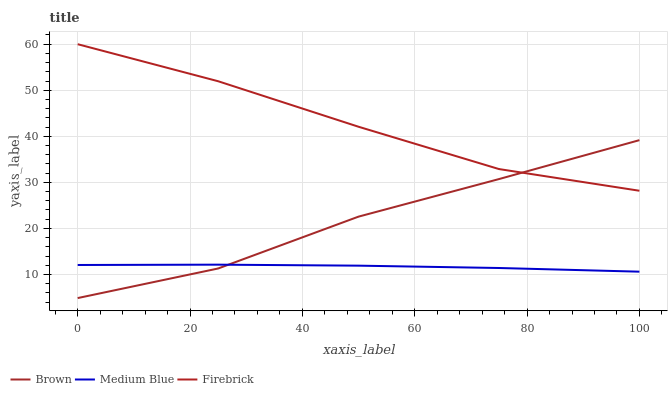Does Medium Blue have the minimum area under the curve?
Answer yes or no. Yes. Does Firebrick have the maximum area under the curve?
Answer yes or no. Yes. Does Firebrick have the minimum area under the curve?
Answer yes or no. No. Does Medium Blue have the maximum area under the curve?
Answer yes or no. No. Is Medium Blue the smoothest?
Answer yes or no. Yes. Is Brown the roughest?
Answer yes or no. Yes. Is Firebrick the smoothest?
Answer yes or no. No. Is Firebrick the roughest?
Answer yes or no. No. Does Brown have the lowest value?
Answer yes or no. Yes. Does Medium Blue have the lowest value?
Answer yes or no. No. Does Firebrick have the highest value?
Answer yes or no. Yes. Does Medium Blue have the highest value?
Answer yes or no. No. Is Medium Blue less than Firebrick?
Answer yes or no. Yes. Is Firebrick greater than Medium Blue?
Answer yes or no. Yes. Does Brown intersect Firebrick?
Answer yes or no. Yes. Is Brown less than Firebrick?
Answer yes or no. No. Is Brown greater than Firebrick?
Answer yes or no. No. Does Medium Blue intersect Firebrick?
Answer yes or no. No. 